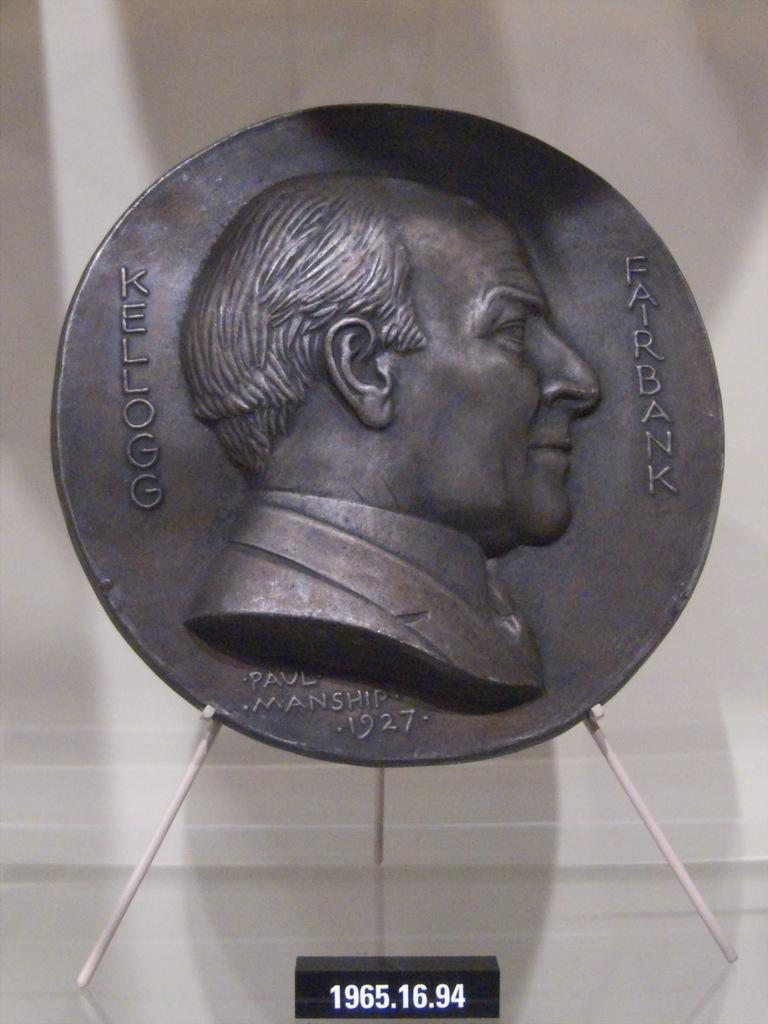Provide a one-sentence caption for the provided image. A relief of Kellogg Fairbank is displayed on a stand. 